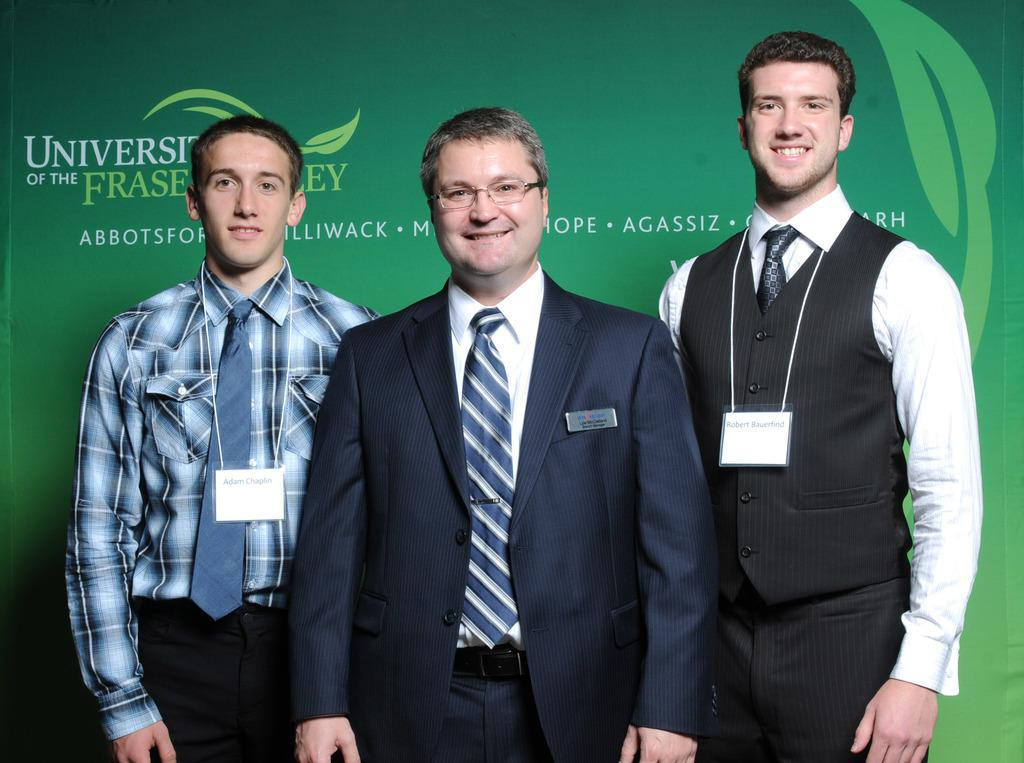How many people are in the image? There are three men in the image. What are the men doing in the image? The men are standing and smiling. Can you describe the clothing of one of the men? One of the men is wearing a suit. What objects are present in the image that might help identify the men? There are name boards in the image. What else can be seen in the background of the image? There is some text visible in the background of the image. Can you see any drawers in the image? There are no drawers present in the image. What type of nest can be seen in the image? There is no nest present in the image. 